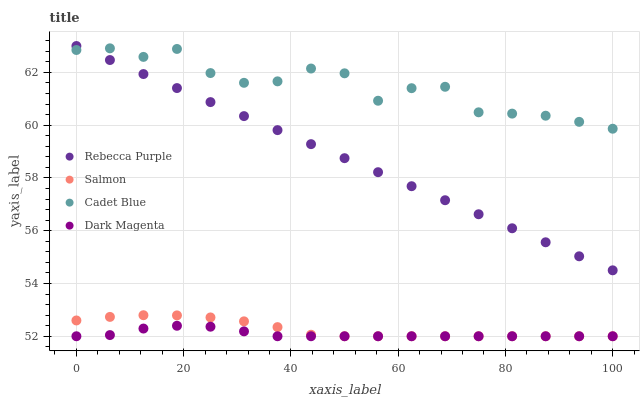Does Dark Magenta have the minimum area under the curve?
Answer yes or no. Yes. Does Cadet Blue have the maximum area under the curve?
Answer yes or no. Yes. Does Salmon have the minimum area under the curve?
Answer yes or no. No. Does Salmon have the maximum area under the curve?
Answer yes or no. No. Is Rebecca Purple the smoothest?
Answer yes or no. Yes. Is Cadet Blue the roughest?
Answer yes or no. Yes. Is Salmon the smoothest?
Answer yes or no. No. Is Salmon the roughest?
Answer yes or no. No. Does Salmon have the lowest value?
Answer yes or no. Yes. Does Rebecca Purple have the lowest value?
Answer yes or no. No. Does Rebecca Purple have the highest value?
Answer yes or no. Yes. Does Salmon have the highest value?
Answer yes or no. No. Is Dark Magenta less than Rebecca Purple?
Answer yes or no. Yes. Is Rebecca Purple greater than Dark Magenta?
Answer yes or no. Yes. Does Rebecca Purple intersect Cadet Blue?
Answer yes or no. Yes. Is Rebecca Purple less than Cadet Blue?
Answer yes or no. No. Is Rebecca Purple greater than Cadet Blue?
Answer yes or no. No. Does Dark Magenta intersect Rebecca Purple?
Answer yes or no. No. 